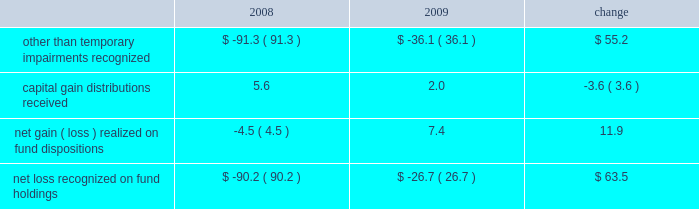Our non-operating investment activity resulted in net losses of $ 12.7 million in 2009 and $ 52.3 million in 2008 .
The improvement of nearly $ 40 million is primarily attributable to a reduction in the other than temporary impairments recognized on our investments in sponsored mutual funds in 2009 versus 2008 .
The table details our related mutual fund investment gains and losses ( in millions ) during the past two years. .
Lower income of $ 16 million from our money market holdings due to the significantly lower interest rate environment offset the improvement experienced with our fund investments .
There is no impairment of any of our mutual fund investments at december 31 , 2009 .
The 2009 provision for income taxes as a percentage of pretax income is 37.1% ( 37.1 % ) , down from 38.4% ( 38.4 % ) in 2008 and .9% ( .9 % ) lower than our present estimate of 38.0% ( 38.0 % ) for the 2010 effective tax rate .
Our 2009 provision includes reductions of prior years 2019 tax provisions and discrete nonrecurring benefits that lowered our 2009 effective tax rate by 1.0% ( 1.0 % ) .
2008 versus 2007 .
Investment advisory revenues decreased 6.3% ( 6.3 % ) , or $ 118 million , to $ 1.76 billion in 2008 as average assets under our management decreased $ 16 billion to $ 358.2 billion .
The average annualized fee rate earned on our assets under management was 49.2 basis points in 2008 , down from the 50.2 basis points earned in 2007 , as lower equity market valuations resulted in a greater percentage of our assets under management being attributable to lower fee fixed income portfolios .
Continuing stress on the financial markets and resulting lower equity valuations as 2008 progressed resulted in lower average assets under our management , lower investment advisory fees and lower net income as compared to prior periods .
Net revenues decreased 5% ( 5 % ) , or $ 112 million , to $ 2.12 billion .
Operating expenses were $ 1.27 billion in 2008 , up 2.9% ( 2.9 % ) or $ 36 million from 2007 .
Net operating income for 2008 decreased $ 147.9 million , or 14.8% ( 14.8 % ) , to $ 848.5 million .
Higher operating expenses in 2008 and decreased market valuations during the latter half of 2008 , which lowered our assets under management and advisory revenues , resulted in our 2008 operating margin declining to 40.1% ( 40.1 % ) from 44.7% ( 44.7 % ) in 2007 .
Non-operating investment losses in 2008 were $ 52.3 million as compared to investment income of $ 80.4 million in 2007 .
Investment losses in 2008 include non-cash charges of $ 91.3 million for the other than temporary impairment of certain of the firm 2019s investments in sponsored mutual funds .
Net income in 2008 fell 27% ( 27 % ) or nearly $ 180 million from 2007 .
Diluted earnings per share , after the retrospective application of new accounting guidance effective in 2009 , decreased to $ 1.81 , down $ .59 or 24.6% ( 24.6 % ) from $ 2.40 in 2007 .
A non-operating charge to recognize other than temporary impairments of our sponsored mutual fund investments reduced diluted earnings per share by $ .21 in 2008 .
Investment advisory revenues earned from the t .
Rowe price mutual funds distributed in the united states decreased 8.5% ( 8.5 % ) , or $ 114.5 million , to $ 1.24 billion .
Average mutual fund assets were $ 216.1 billion in 2008 , down $ 16.7 billion from 2007 .
Mutual fund assets at december 31 , 2008 , were $ 164.4 billion , down $ 81.6 billion from the end of 2007 .
Net inflows to the mutual funds during 2008 were $ 3.9 billion , including $ 1.9 billion to the money funds , $ 1.1 billion to the bond funds , and $ .9 billion to the stock funds .
The value , equity index 500 , and emerging markets stock funds combined to add $ 4.1 billion , while the mid-cap growth and equity income stock funds had net redemptions of $ 2.2 billion .
Net fund inflows of $ 6.2 billion originated in our target-date retirement funds , which in turn invest in other t .
Rowe price funds .
Fund net inflow amounts in 2008 are presented net of $ 1.3 billion that was transferred to target-date trusts from the retirement funds during the year .
Decreases in market valuations and income not reinvested lowered our mutual fund assets under management by $ 85.5 billion during 2008 .
Investment advisory revenues earned on the other investment portfolios that we manage decreased $ 3.6 million to $ 522.2 million .
Average assets in these portfolios were $ 142.1 billion during 2008 , up slightly from $ 141.4 billion in 2007 .
These minor changes , each less than 1% ( 1 % ) , are attributable to the timing of declining equity market valuations and cash flows among our separate account and subadvised portfolios .
Net inflows , primarily from institutional investors , were $ 13.2 billion during 2008 , including the $ 1.3 billion transferred from the retirement funds to target-date trusts .
Decreases in market valuations , net of income , lowered our assets under management in these portfolios by $ 55.3 billion during 2008 .
Management 2019s discussion & analysis 21 .
What was the value , in millions of dollars , of net revenues in 2007? 
Computations: ((2.12 * 1000) + 112)
Answer: 2232.0. 